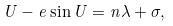<formula> <loc_0><loc_0><loc_500><loc_500>U - e \sin U = n \lambda + \sigma ,</formula> 